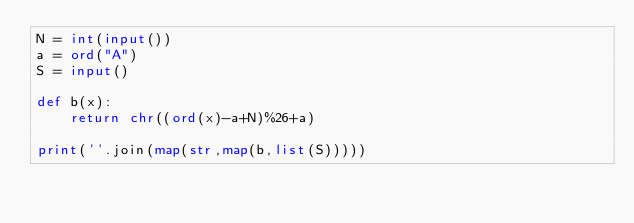<code> <loc_0><loc_0><loc_500><loc_500><_Python_>N = int(input())
a = ord("A")
S = input()

def b(x):
    return chr((ord(x)-a+N)%26+a)

print(''.join(map(str,map(b,list(S)))))</code> 